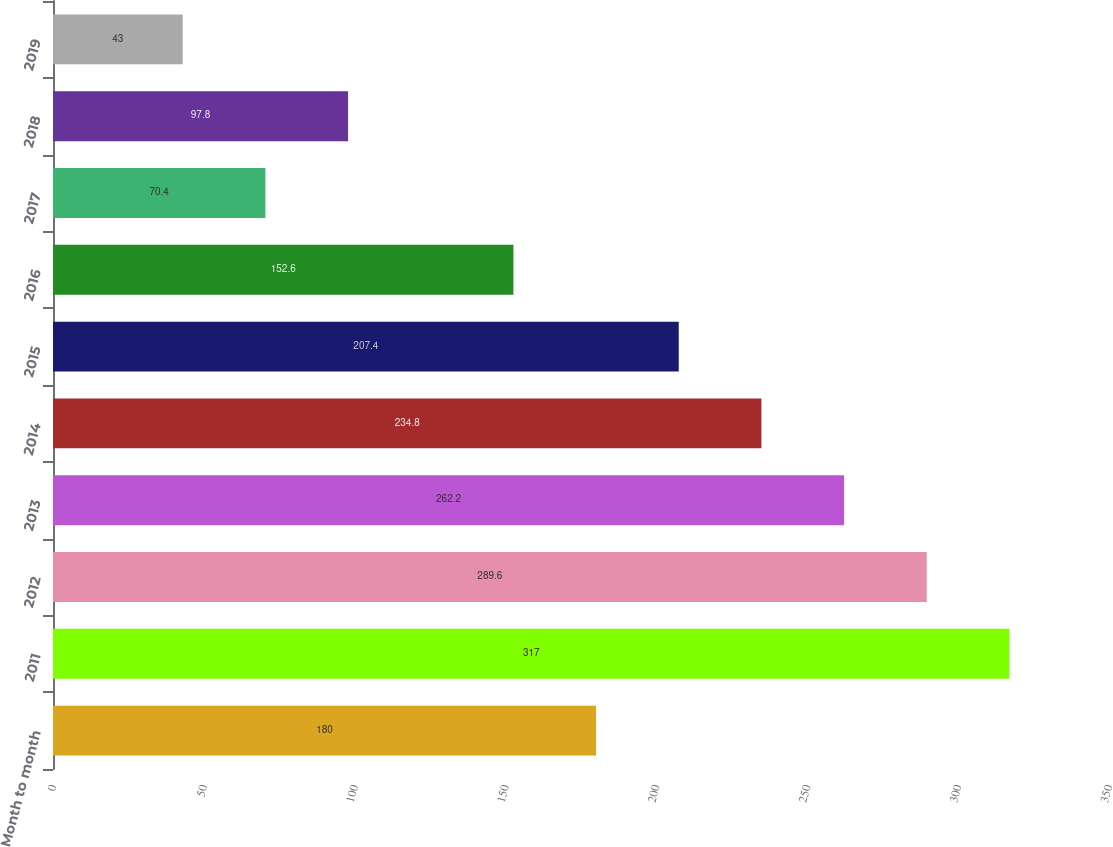<chart> <loc_0><loc_0><loc_500><loc_500><bar_chart><fcel>Month to month<fcel>2011<fcel>2012<fcel>2013<fcel>2014<fcel>2015<fcel>2016<fcel>2017<fcel>2018<fcel>2019<nl><fcel>180<fcel>317<fcel>289.6<fcel>262.2<fcel>234.8<fcel>207.4<fcel>152.6<fcel>70.4<fcel>97.8<fcel>43<nl></chart> 